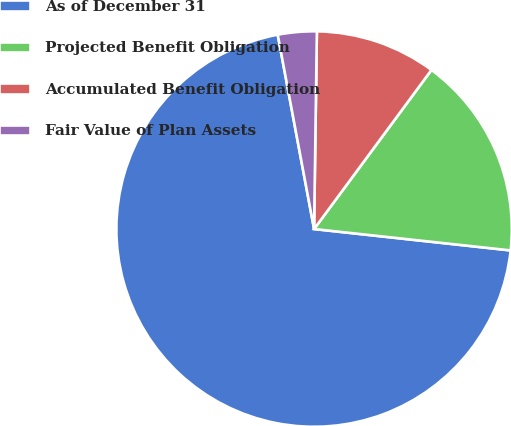<chart> <loc_0><loc_0><loc_500><loc_500><pie_chart><fcel>As of December 31<fcel>Projected Benefit Obligation<fcel>Accumulated Benefit Obligation<fcel>Fair Value of Plan Assets<nl><fcel>70.33%<fcel>16.61%<fcel>9.89%<fcel>3.17%<nl></chart> 